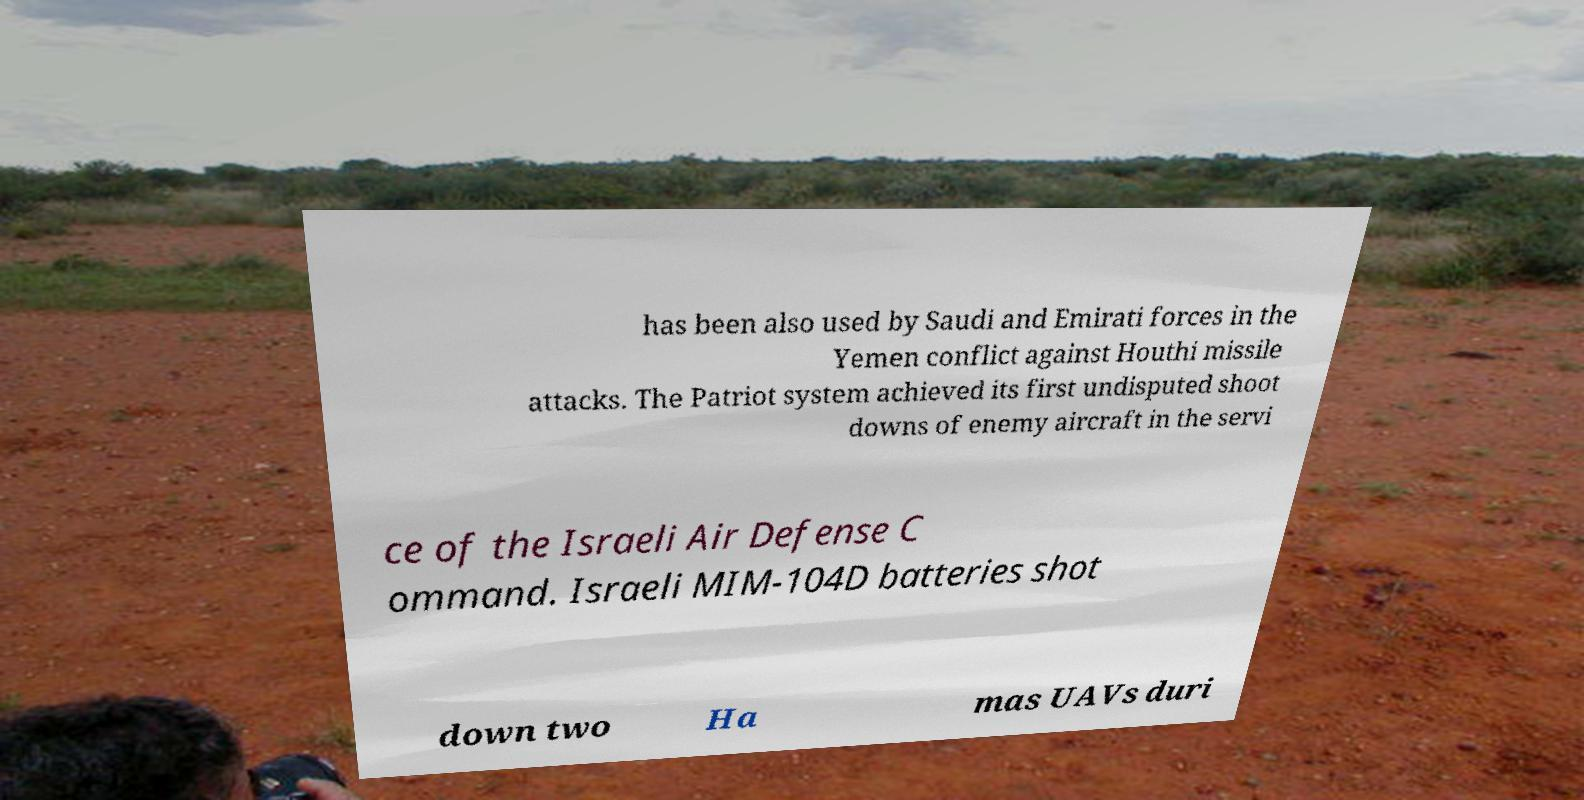Can you accurately transcribe the text from the provided image for me? has been also used by Saudi and Emirati forces in the Yemen conflict against Houthi missile attacks. The Patriot system achieved its first undisputed shoot downs of enemy aircraft in the servi ce of the Israeli Air Defense C ommand. Israeli MIM-104D batteries shot down two Ha mas UAVs duri 